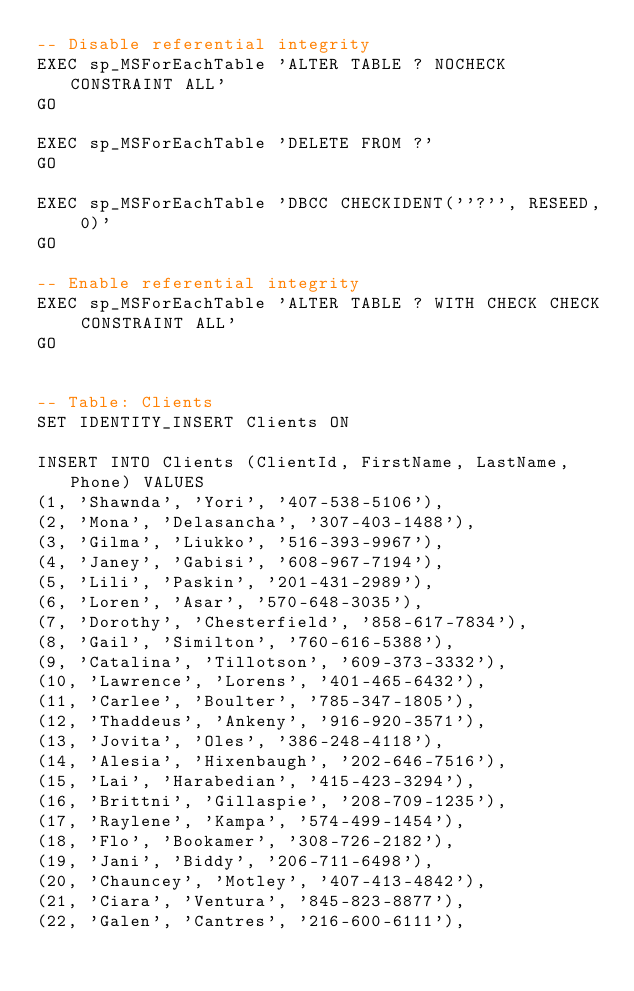Convert code to text. <code><loc_0><loc_0><loc_500><loc_500><_SQL_>-- Disable referential integrity
EXEC sp_MSForEachTable 'ALTER TABLE ? NOCHECK CONSTRAINT ALL'
GO

EXEC sp_MSForEachTable 'DELETE FROM ?'
GO

EXEC sp_MSForEachTable 'DBCC CHECKIDENT(''?'', RESEED, 0)'
GO

-- Enable referential integrity 
EXEC sp_MSForEachTable 'ALTER TABLE ? WITH CHECK CHECK CONSTRAINT ALL'
GO


-- Table: Clients
SET IDENTITY_INSERT Clients ON

INSERT INTO Clients (ClientId, FirstName, LastName, Phone) VALUES
(1, 'Shawnda', 'Yori', '407-538-5106'),
(2, 'Mona', 'Delasancha', '307-403-1488'),
(3, 'Gilma', 'Liukko', '516-393-9967'),
(4, 'Janey', 'Gabisi', '608-967-7194'),
(5, 'Lili', 'Paskin', '201-431-2989'),
(6, 'Loren', 'Asar', '570-648-3035'),
(7, 'Dorothy', 'Chesterfield', '858-617-7834'),
(8, 'Gail', 'Similton', '760-616-5388'),
(9, 'Catalina', 'Tillotson', '609-373-3332'),
(10, 'Lawrence', 'Lorens', '401-465-6432'),
(11, 'Carlee', 'Boulter', '785-347-1805'),
(12, 'Thaddeus', 'Ankeny', '916-920-3571'),
(13, 'Jovita', 'Oles', '386-248-4118'),
(14, 'Alesia', 'Hixenbaugh', '202-646-7516'),
(15, 'Lai', 'Harabedian', '415-423-3294'),
(16, 'Brittni', 'Gillaspie', '208-709-1235'),
(17, 'Raylene', 'Kampa', '574-499-1454'),
(18, 'Flo', 'Bookamer', '308-726-2182'),
(19, 'Jani', 'Biddy', '206-711-6498'),
(20, 'Chauncey', 'Motley', '407-413-4842'),
(21, 'Ciara', 'Ventura', '845-823-8877'),
(22, 'Galen', 'Cantres', '216-600-6111'),</code> 